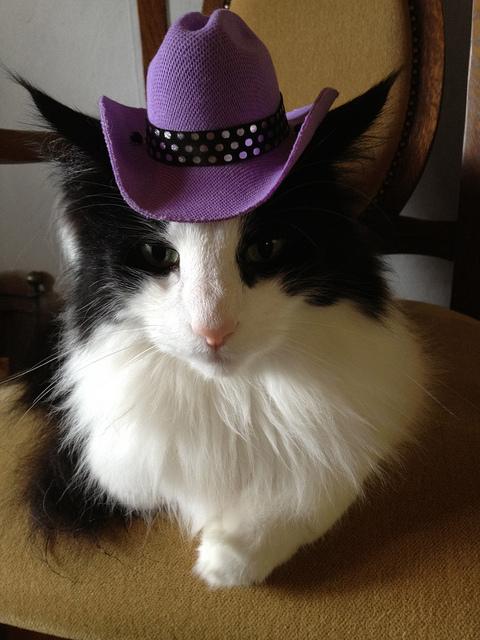What is the hat made of?
Give a very brief answer. Felt. Is the cat female?
Answer briefly. Yes. What kind of animal is this?
Be succinct. Cat. What colors are the hat?
Keep it brief. Purple. What color hat is this cat wearing?
Write a very short answer. Purple. 